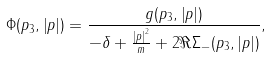Convert formula to latex. <formula><loc_0><loc_0><loc_500><loc_500>\Phi ( p _ { 3 } , \left | { p } \right | ) = \frac { g ( p _ { 3 } , \left | { p } \right | ) } { - \delta + \frac { \left | { p } \right | ^ { 2 } } { m } + 2 \Re \Sigma _ { - } ( p _ { 3 } , \left | { p } \right | ) } ,</formula> 